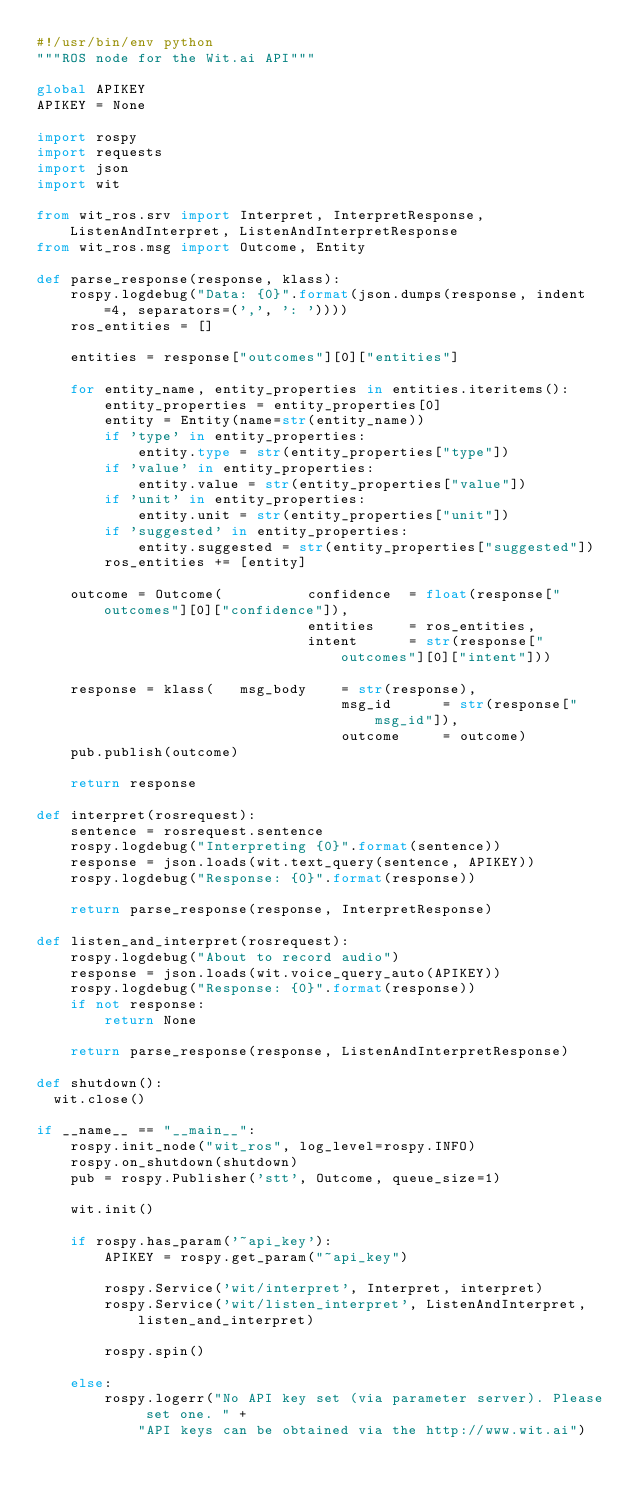<code> <loc_0><loc_0><loc_500><loc_500><_Python_>#!/usr/bin/env python
"""ROS node for the Wit.ai API"""

global APIKEY
APIKEY = None

import rospy
import requests
import json
import wit

from wit_ros.srv import Interpret, InterpretResponse, ListenAndInterpret, ListenAndInterpretResponse
from wit_ros.msg import Outcome, Entity

def parse_response(response, klass):
    rospy.logdebug("Data: {0}".format(json.dumps(response, indent=4, separators=(',', ': '))))
    ros_entities = []

    entities = response["outcomes"][0]["entities"]

    for entity_name, entity_properties in entities.iteritems():
        entity_properties = entity_properties[0]
        entity = Entity(name=str(entity_name))
        if 'type' in entity_properties:
            entity.type = str(entity_properties["type"])
        if 'value' in entity_properties:
            entity.value = str(entity_properties["value"])
        if 'unit' in entity_properties:
            entity.unit = str(entity_properties["unit"])
        if 'suggested' in entity_properties:
            entity.suggested = str(entity_properties["suggested"])
        ros_entities += [entity]

    outcome = Outcome(          confidence  = float(response["outcomes"][0]["confidence"]),
                                entities    = ros_entities,
                                intent      = str(response["outcomes"][0]["intent"]))

    response = klass(   msg_body    = str(response),
                                    msg_id      = str(response["msg_id"]),
                                    outcome     = outcome)
    pub.publish(outcome)

    return response

def interpret(rosrequest):
    sentence = rosrequest.sentence
    rospy.logdebug("Interpreting {0}".format(sentence))
    response = json.loads(wit.text_query(sentence, APIKEY))
    rospy.logdebug("Response: {0}".format(response))

    return parse_response(response, InterpretResponse)

def listen_and_interpret(rosrequest):
    rospy.logdebug("About to record audio")
    response = json.loads(wit.voice_query_auto(APIKEY))
    rospy.logdebug("Response: {0}".format(response))
    if not response:
        return None

    return parse_response(response, ListenAndInterpretResponse)

def shutdown():
  wit.close()

if __name__ == "__main__":
    rospy.init_node("wit_ros", log_level=rospy.INFO)
    rospy.on_shutdown(shutdown)
    pub = rospy.Publisher('stt', Outcome, queue_size=1)

    wit.init()

    if rospy.has_param('~api_key'):
        APIKEY = rospy.get_param("~api_key")

        rospy.Service('wit/interpret', Interpret, interpret)
        rospy.Service('wit/listen_interpret', ListenAndInterpret, listen_and_interpret)

        rospy.spin()

    else:
        rospy.logerr("No API key set (via parameter server). Please set one. " +
            "API keys can be obtained via the http://www.wit.ai")
</code> 